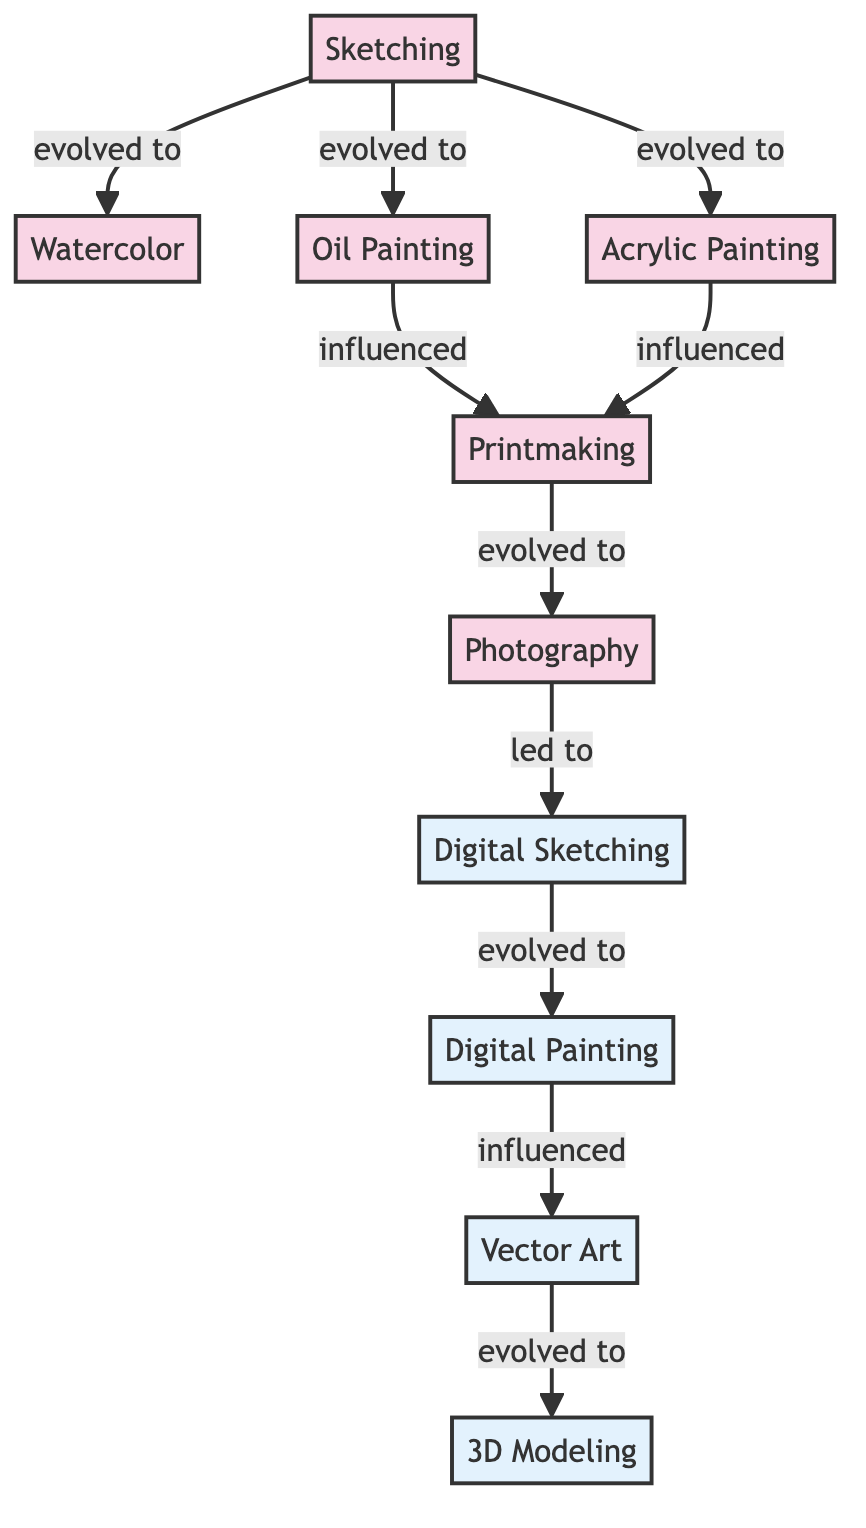What is the first step in the evolution of art illustration? The diagram indicates that "Sketching" is the initial technique depicted in the flow of the evolution. Therefore, it is the starting point.
Answer: Sketching Which traditional technique influenced Printmaking? The diagram shows two paths leading to Printmaking: one from "Oil Painting" and the other from "Acrylic Painting." Thus, both techniques have influenced Printmaking.
Answer: Oil Painting and Acrylic Painting How many traditional techniques are shown in the diagram? By counting the nodes listed under the 'traditional' class, we find five techniques: Sketching, Watercolor, Oil Painting, Acrylic Painting, and Printmaking. This totals to five traditional techniques.
Answer: 5 What digital technique evolved from Digital Sketching? According to the diagram, Digital Painting evolves directly from Digital Sketching, indicating a progressive step in the digital art evolution.
Answer: Digital Painting Which technique comes after Digital Painting in the flow? The diagram illustrates that after Digital Painting, the next evolution is to Vector Art, showing the sequential relationship between these techniques.
Answer: Vector Art How many edges connect the traditional techniques to digital techniques? Analyzing the connections in the diagram, we see that traditional techniques lead specifically into Digital Sketching, which then progresses into Digital Painting and further into Vector Art and thus into 3D Modeling. The combinations yield six edges connecting traditional to digital.
Answer: 6 Is Photography considered a traditional or digital technique? The diagram places Photography under the 'traditional' classification, as it evolves from the printmaking phase of the artistic flow, linking traditional methods to later digital innovations.
Answer: Traditional Which artistic technique leads to 3D Modeling? The chain indicates that Vector Art evolves into 3D Modeling, demonstrating how various techniques have built upon one another through the progression in digital art.
Answer: Vector Art 